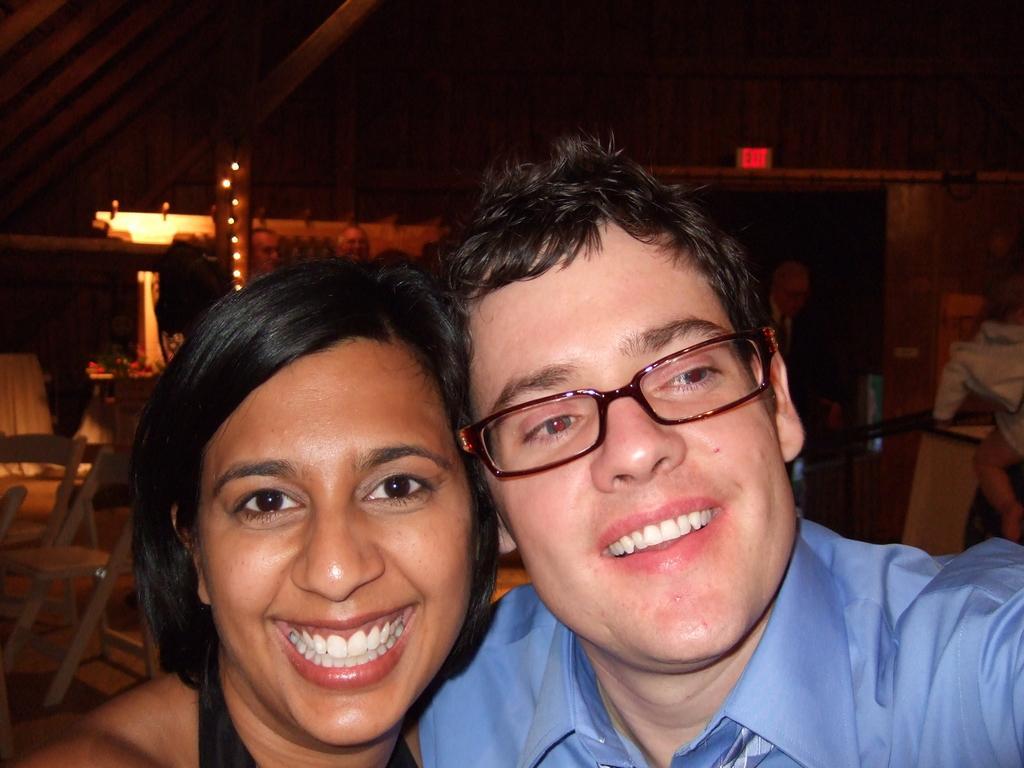How would you summarize this image in a sentence or two? In this picture we can see a boy wearing blue color t-shirt smiling and taking a selfie with the girl standing beside him. Behind we can see wooden chair and decorative lights hanging in the back Above we can see wooden shed. 